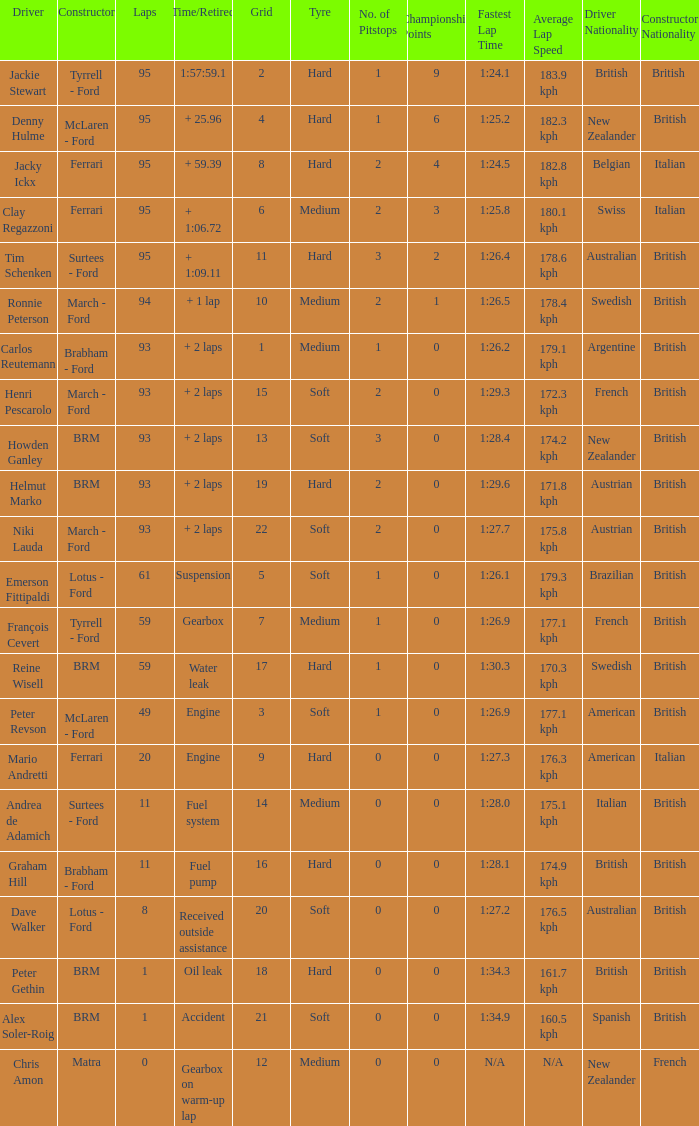How many grids does dave walker have? 1.0. 